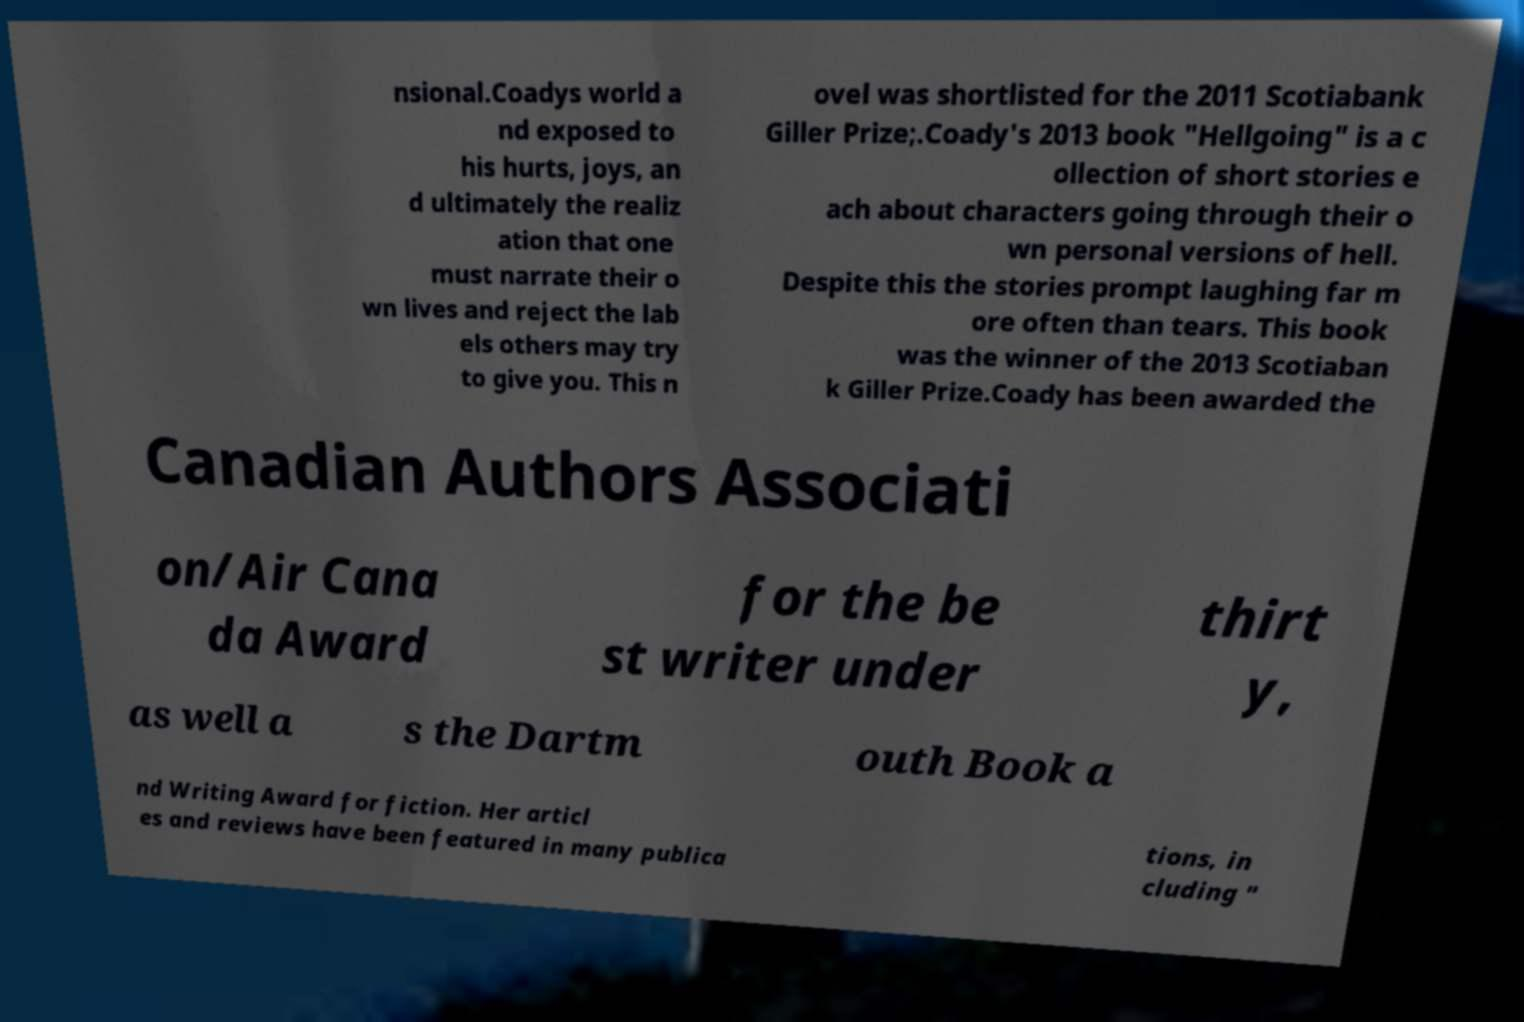Could you extract and type out the text from this image? nsional.Coadys world a nd exposed to his hurts, joys, an d ultimately the realiz ation that one must narrate their o wn lives and reject the lab els others may try to give you. This n ovel was shortlisted for the 2011 Scotiabank Giller Prize;.Coady's 2013 book "Hellgoing" is a c ollection of short stories e ach about characters going through their o wn personal versions of hell. Despite this the stories prompt laughing far m ore often than tears. This book was the winner of the 2013 Scotiaban k Giller Prize.Coady has been awarded the Canadian Authors Associati on/Air Cana da Award for the be st writer under thirt y, as well a s the Dartm outh Book a nd Writing Award for fiction. Her articl es and reviews have been featured in many publica tions, in cluding " 